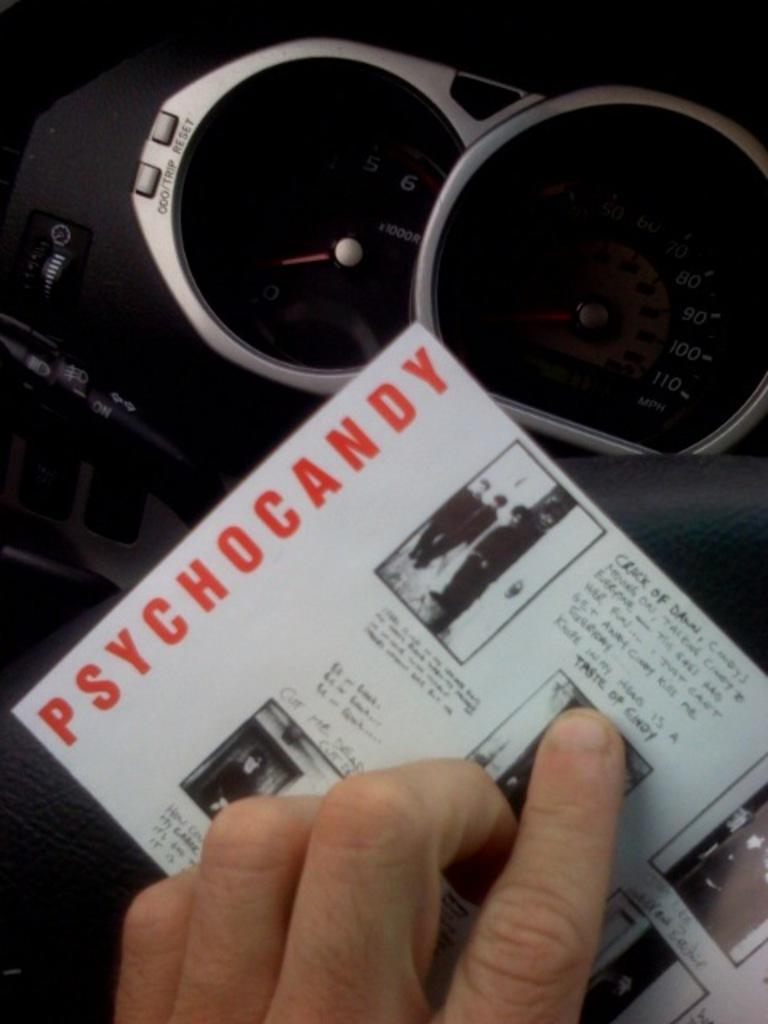What body part is visible in the image? There are fingers visible in the image. What is on the paper that is visible in the image? There is a paper with writing in the image. What type of objects can be seen in the background of the image? There are speedometers and buttons in the background of the image. What type of egg is being used as an example in the image? There is no egg present in the image. What language is used in the writing on the paper? The language used in the writing on the paper cannot be determined from the image alone. 